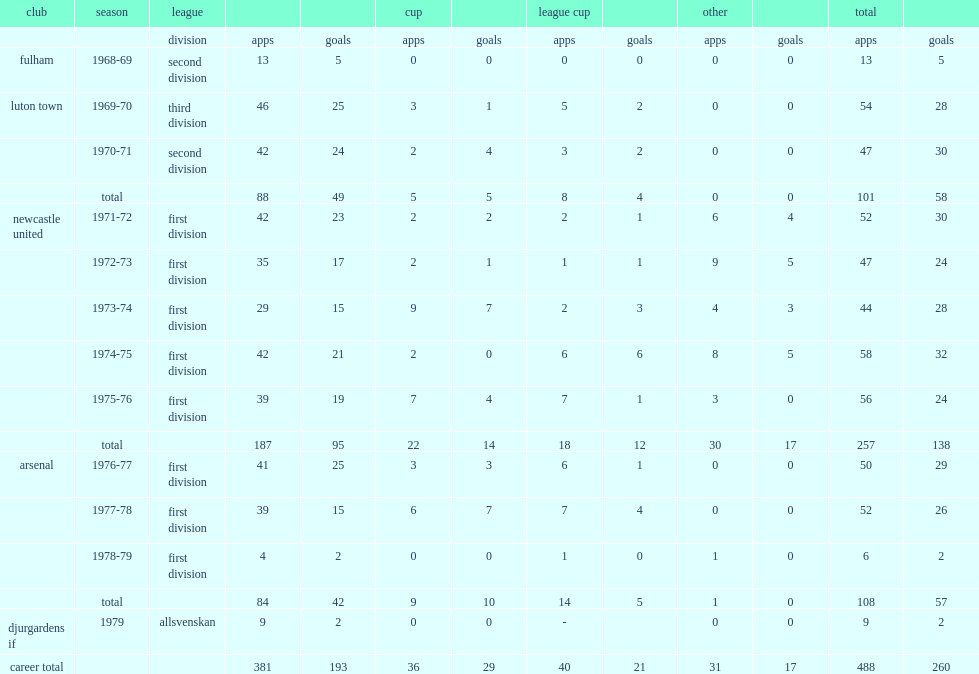In his career, how many goals did macdonald score in total? 193.0. 